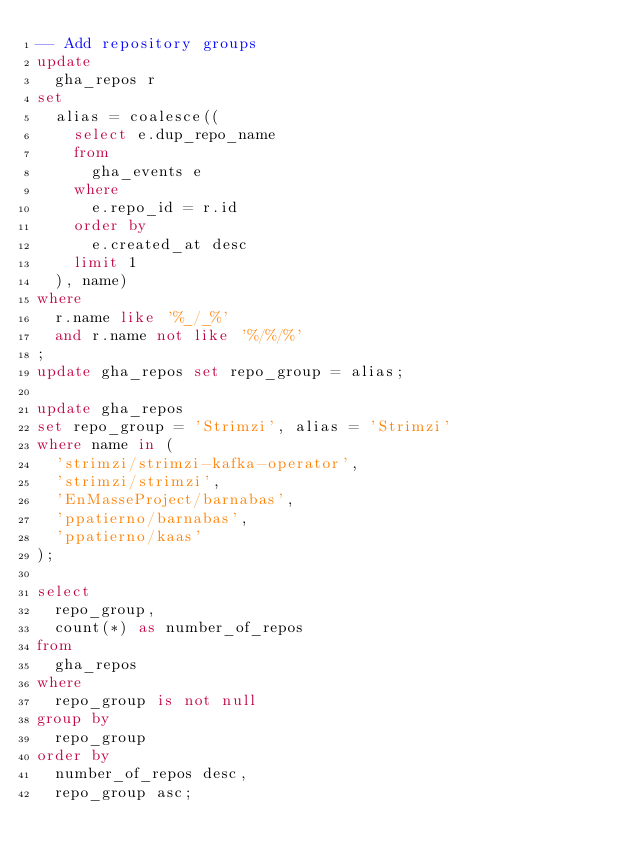<code> <loc_0><loc_0><loc_500><loc_500><_SQL_>-- Add repository groups
update
  gha_repos r
set
  alias = coalesce((
    select e.dup_repo_name
    from
      gha_events e
    where
      e.repo_id = r.id
    order by
      e.created_at desc
    limit 1
  ), name)
where
  r.name like '%_/_%'
  and r.name not like '%/%/%'
;
update gha_repos set repo_group = alias;

update gha_repos
set repo_group = 'Strimzi', alias = 'Strimzi'
where name in (
  'strimzi/strimzi-kafka-operator',
  'strimzi/strimzi',
  'EnMasseProject/barnabas',
  'ppatierno/barnabas',
  'ppatierno/kaas'
);

select
  repo_group,
  count(*) as number_of_repos
from
  gha_repos
where
  repo_group is not null
group by
  repo_group
order by
  number_of_repos desc,
  repo_group asc;
</code> 